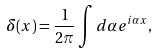<formula> <loc_0><loc_0><loc_500><loc_500>\delta ( x ) = \frac { 1 } { 2 \pi } \int d \alpha e ^ { i \alpha x } ,</formula> 